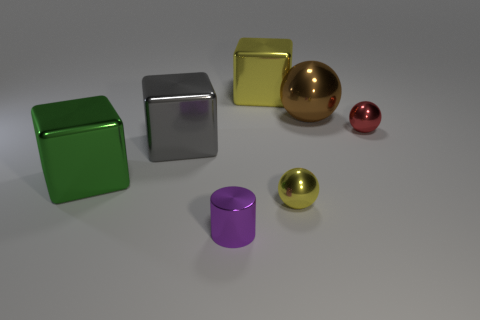Subtract all large brown spheres. How many spheres are left? 2 Add 1 tiny purple rubber spheres. How many objects exist? 8 Subtract all green cubes. How many cubes are left? 2 Subtract all balls. How many objects are left? 4 Add 6 small yellow metallic things. How many small yellow metallic things exist? 7 Subtract 1 brown spheres. How many objects are left? 6 Subtract 1 spheres. How many spheres are left? 2 Subtract all yellow cylinders. Subtract all blue cubes. How many cylinders are left? 1 Subtract all cyan cubes. How many yellow spheres are left? 1 Subtract all big gray blocks. Subtract all tiny green blocks. How many objects are left? 6 